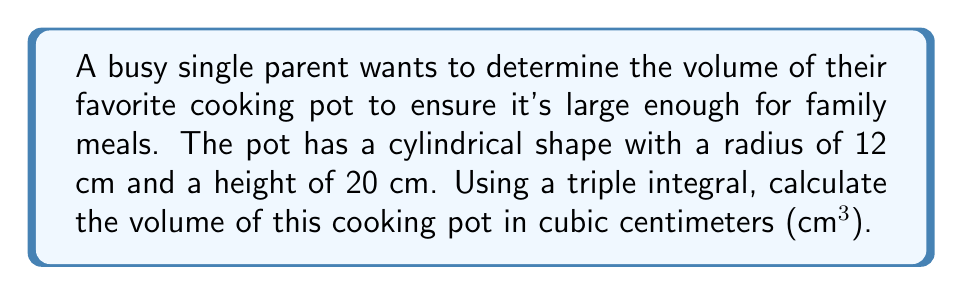Teach me how to tackle this problem. Let's approach this step-by-step:

1) For a cylindrical pot, we can use cylindrical coordinates $(r, \theta, z)$.

2) The volume of the pot can be expressed as a triple integral:

   $$V = \iiint_V dV = \int_0^{2\pi} \int_0^R \int_0^H r \, dz \, dr \, d\theta$$

   where $R$ is the radius and $H$ is the height of the pot.

3) Given: $R = 12$ cm and $H = 20$ cm.

4) Let's evaluate the integral:

   $$V = \int_0^{2\pi} \int_0^{12} \int_0^{20} r \, dz \, dr \, d\theta$$

5) First, integrate with respect to $z$:

   $$V = \int_0^{2\pi} \int_0^{12} [rz]_0^{20} \, dr \, d\theta = \int_0^{2\pi} \int_0^{12} 20r \, dr \, d\theta$$

6) Now, integrate with respect to $r$:

   $$V = \int_0^{2\pi} [10r^2]_0^{12} \, d\theta = \int_0^{2\pi} 1440 \, d\theta$$

7) Finally, integrate with respect to $\theta$:

   $$V = [1440\theta]_0^{2\pi} = 1440 \cdot 2\pi = 2880\pi$$

Therefore, the volume of the pot is $2880\pi$ cubic centimeters.
Answer: $2880\pi$ cm³ 